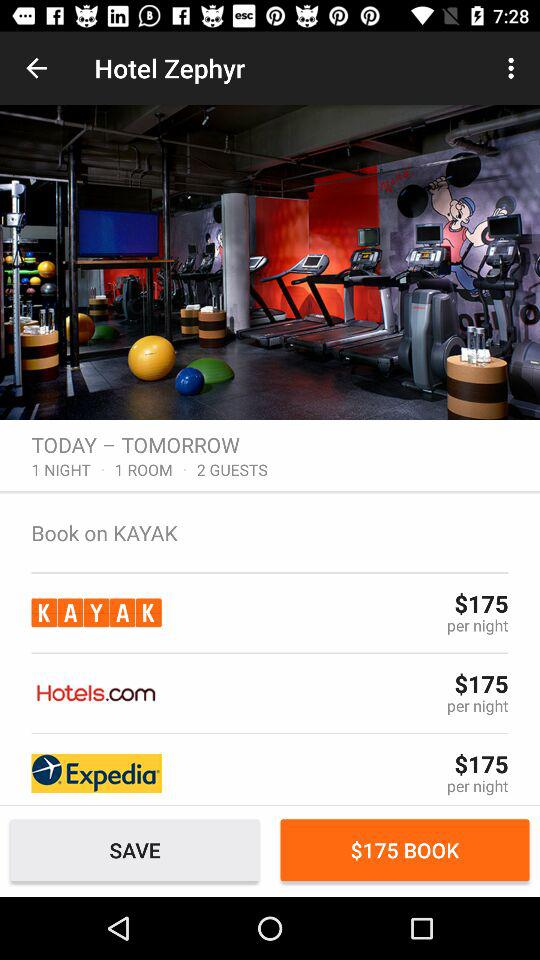What is the per-night cost of a room on Kayak?
Answer the question using a single word or phrase. It costs $175. 